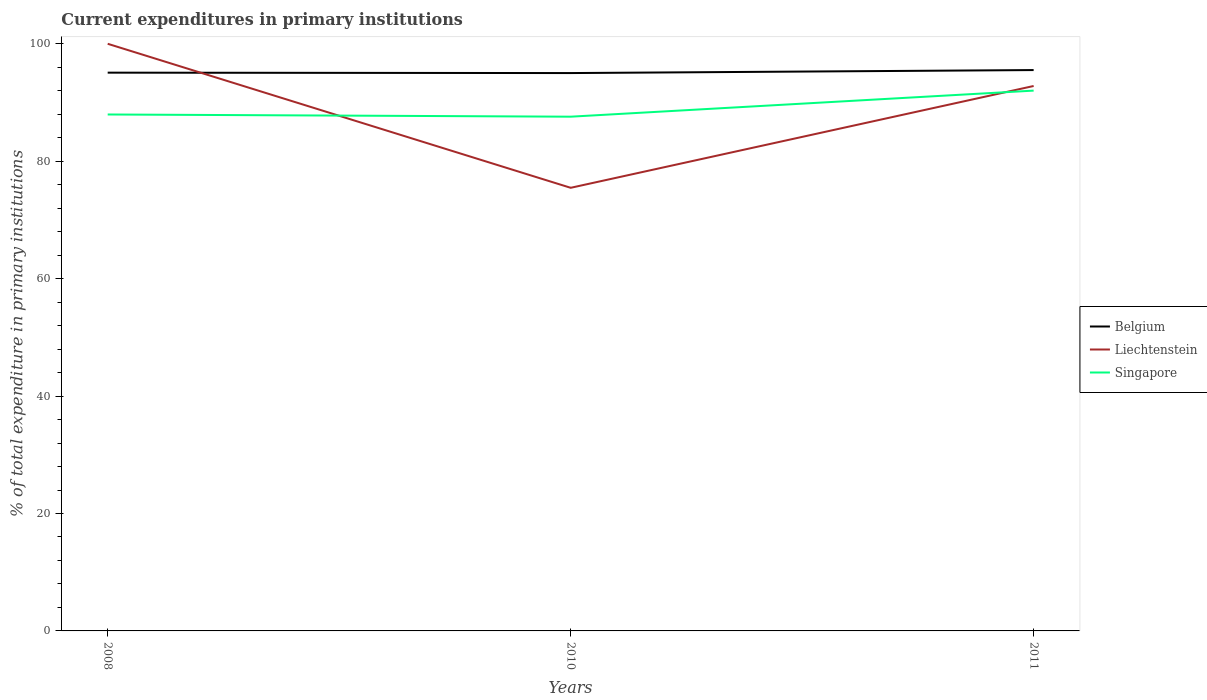How many different coloured lines are there?
Offer a very short reply. 3. Does the line corresponding to Liechtenstein intersect with the line corresponding to Singapore?
Your answer should be compact. Yes. Across all years, what is the maximum current expenditures in primary institutions in Liechtenstein?
Give a very brief answer. 75.47. In which year was the current expenditures in primary institutions in Belgium maximum?
Ensure brevity in your answer.  2010. What is the total current expenditures in primary institutions in Liechtenstein in the graph?
Offer a terse response. 24.53. What is the difference between the highest and the second highest current expenditures in primary institutions in Liechtenstein?
Offer a very short reply. 24.53. What is the difference between the highest and the lowest current expenditures in primary institutions in Singapore?
Give a very brief answer. 1. Is the current expenditures in primary institutions in Belgium strictly greater than the current expenditures in primary institutions in Liechtenstein over the years?
Your response must be concise. No. How many lines are there?
Keep it short and to the point. 3. What is the difference between two consecutive major ticks on the Y-axis?
Make the answer very short. 20. Does the graph contain any zero values?
Offer a terse response. No. Where does the legend appear in the graph?
Provide a short and direct response. Center right. How many legend labels are there?
Ensure brevity in your answer.  3. How are the legend labels stacked?
Provide a succinct answer. Vertical. What is the title of the graph?
Offer a terse response. Current expenditures in primary institutions. What is the label or title of the Y-axis?
Ensure brevity in your answer.  % of total expenditure in primary institutions. What is the % of total expenditure in primary institutions in Belgium in 2008?
Offer a terse response. 95.08. What is the % of total expenditure in primary institutions in Singapore in 2008?
Your response must be concise. 87.96. What is the % of total expenditure in primary institutions in Belgium in 2010?
Provide a short and direct response. 95.01. What is the % of total expenditure in primary institutions of Liechtenstein in 2010?
Offer a very short reply. 75.47. What is the % of total expenditure in primary institutions of Singapore in 2010?
Provide a short and direct response. 87.58. What is the % of total expenditure in primary institutions in Belgium in 2011?
Your answer should be very brief. 95.52. What is the % of total expenditure in primary institutions of Liechtenstein in 2011?
Give a very brief answer. 92.81. What is the % of total expenditure in primary institutions in Singapore in 2011?
Provide a succinct answer. 92.02. Across all years, what is the maximum % of total expenditure in primary institutions of Belgium?
Offer a terse response. 95.52. Across all years, what is the maximum % of total expenditure in primary institutions of Liechtenstein?
Make the answer very short. 100. Across all years, what is the maximum % of total expenditure in primary institutions of Singapore?
Your answer should be very brief. 92.02. Across all years, what is the minimum % of total expenditure in primary institutions in Belgium?
Provide a succinct answer. 95.01. Across all years, what is the minimum % of total expenditure in primary institutions in Liechtenstein?
Your answer should be very brief. 75.47. Across all years, what is the minimum % of total expenditure in primary institutions in Singapore?
Your answer should be very brief. 87.58. What is the total % of total expenditure in primary institutions of Belgium in the graph?
Make the answer very short. 285.62. What is the total % of total expenditure in primary institutions of Liechtenstein in the graph?
Give a very brief answer. 268.28. What is the total % of total expenditure in primary institutions in Singapore in the graph?
Keep it short and to the point. 267.56. What is the difference between the % of total expenditure in primary institutions in Belgium in 2008 and that in 2010?
Offer a very short reply. 0.07. What is the difference between the % of total expenditure in primary institutions in Liechtenstein in 2008 and that in 2010?
Your response must be concise. 24.53. What is the difference between the % of total expenditure in primary institutions in Singapore in 2008 and that in 2010?
Offer a very short reply. 0.37. What is the difference between the % of total expenditure in primary institutions in Belgium in 2008 and that in 2011?
Provide a short and direct response. -0.44. What is the difference between the % of total expenditure in primary institutions of Liechtenstein in 2008 and that in 2011?
Provide a short and direct response. 7.19. What is the difference between the % of total expenditure in primary institutions in Singapore in 2008 and that in 2011?
Your answer should be compact. -4.07. What is the difference between the % of total expenditure in primary institutions of Belgium in 2010 and that in 2011?
Make the answer very short. -0.51. What is the difference between the % of total expenditure in primary institutions in Liechtenstein in 2010 and that in 2011?
Provide a short and direct response. -17.34. What is the difference between the % of total expenditure in primary institutions of Singapore in 2010 and that in 2011?
Your answer should be very brief. -4.44. What is the difference between the % of total expenditure in primary institutions in Belgium in 2008 and the % of total expenditure in primary institutions in Liechtenstein in 2010?
Make the answer very short. 19.61. What is the difference between the % of total expenditure in primary institutions in Belgium in 2008 and the % of total expenditure in primary institutions in Singapore in 2010?
Provide a succinct answer. 7.5. What is the difference between the % of total expenditure in primary institutions of Liechtenstein in 2008 and the % of total expenditure in primary institutions of Singapore in 2010?
Your answer should be very brief. 12.42. What is the difference between the % of total expenditure in primary institutions of Belgium in 2008 and the % of total expenditure in primary institutions of Liechtenstein in 2011?
Ensure brevity in your answer.  2.27. What is the difference between the % of total expenditure in primary institutions of Belgium in 2008 and the % of total expenditure in primary institutions of Singapore in 2011?
Make the answer very short. 3.06. What is the difference between the % of total expenditure in primary institutions of Liechtenstein in 2008 and the % of total expenditure in primary institutions of Singapore in 2011?
Offer a terse response. 7.98. What is the difference between the % of total expenditure in primary institutions of Belgium in 2010 and the % of total expenditure in primary institutions of Liechtenstein in 2011?
Make the answer very short. 2.2. What is the difference between the % of total expenditure in primary institutions in Belgium in 2010 and the % of total expenditure in primary institutions in Singapore in 2011?
Provide a short and direct response. 2.99. What is the difference between the % of total expenditure in primary institutions in Liechtenstein in 2010 and the % of total expenditure in primary institutions in Singapore in 2011?
Your response must be concise. -16.55. What is the average % of total expenditure in primary institutions of Belgium per year?
Give a very brief answer. 95.21. What is the average % of total expenditure in primary institutions in Liechtenstein per year?
Ensure brevity in your answer.  89.43. What is the average % of total expenditure in primary institutions in Singapore per year?
Make the answer very short. 89.19. In the year 2008, what is the difference between the % of total expenditure in primary institutions in Belgium and % of total expenditure in primary institutions in Liechtenstein?
Keep it short and to the point. -4.92. In the year 2008, what is the difference between the % of total expenditure in primary institutions of Belgium and % of total expenditure in primary institutions of Singapore?
Make the answer very short. 7.12. In the year 2008, what is the difference between the % of total expenditure in primary institutions in Liechtenstein and % of total expenditure in primary institutions in Singapore?
Give a very brief answer. 12.04. In the year 2010, what is the difference between the % of total expenditure in primary institutions of Belgium and % of total expenditure in primary institutions of Liechtenstein?
Your response must be concise. 19.54. In the year 2010, what is the difference between the % of total expenditure in primary institutions of Belgium and % of total expenditure in primary institutions of Singapore?
Ensure brevity in your answer.  7.43. In the year 2010, what is the difference between the % of total expenditure in primary institutions of Liechtenstein and % of total expenditure in primary institutions of Singapore?
Keep it short and to the point. -12.11. In the year 2011, what is the difference between the % of total expenditure in primary institutions of Belgium and % of total expenditure in primary institutions of Liechtenstein?
Offer a terse response. 2.71. In the year 2011, what is the difference between the % of total expenditure in primary institutions of Belgium and % of total expenditure in primary institutions of Singapore?
Ensure brevity in your answer.  3.5. In the year 2011, what is the difference between the % of total expenditure in primary institutions of Liechtenstein and % of total expenditure in primary institutions of Singapore?
Your response must be concise. 0.79. What is the ratio of the % of total expenditure in primary institutions of Liechtenstein in 2008 to that in 2010?
Your response must be concise. 1.32. What is the ratio of the % of total expenditure in primary institutions in Liechtenstein in 2008 to that in 2011?
Keep it short and to the point. 1.08. What is the ratio of the % of total expenditure in primary institutions of Singapore in 2008 to that in 2011?
Offer a very short reply. 0.96. What is the ratio of the % of total expenditure in primary institutions in Belgium in 2010 to that in 2011?
Offer a very short reply. 0.99. What is the ratio of the % of total expenditure in primary institutions of Liechtenstein in 2010 to that in 2011?
Offer a very short reply. 0.81. What is the ratio of the % of total expenditure in primary institutions in Singapore in 2010 to that in 2011?
Offer a very short reply. 0.95. What is the difference between the highest and the second highest % of total expenditure in primary institutions in Belgium?
Give a very brief answer. 0.44. What is the difference between the highest and the second highest % of total expenditure in primary institutions in Liechtenstein?
Keep it short and to the point. 7.19. What is the difference between the highest and the second highest % of total expenditure in primary institutions in Singapore?
Your answer should be compact. 4.07. What is the difference between the highest and the lowest % of total expenditure in primary institutions of Belgium?
Your response must be concise. 0.51. What is the difference between the highest and the lowest % of total expenditure in primary institutions of Liechtenstein?
Ensure brevity in your answer.  24.53. What is the difference between the highest and the lowest % of total expenditure in primary institutions in Singapore?
Offer a very short reply. 4.44. 